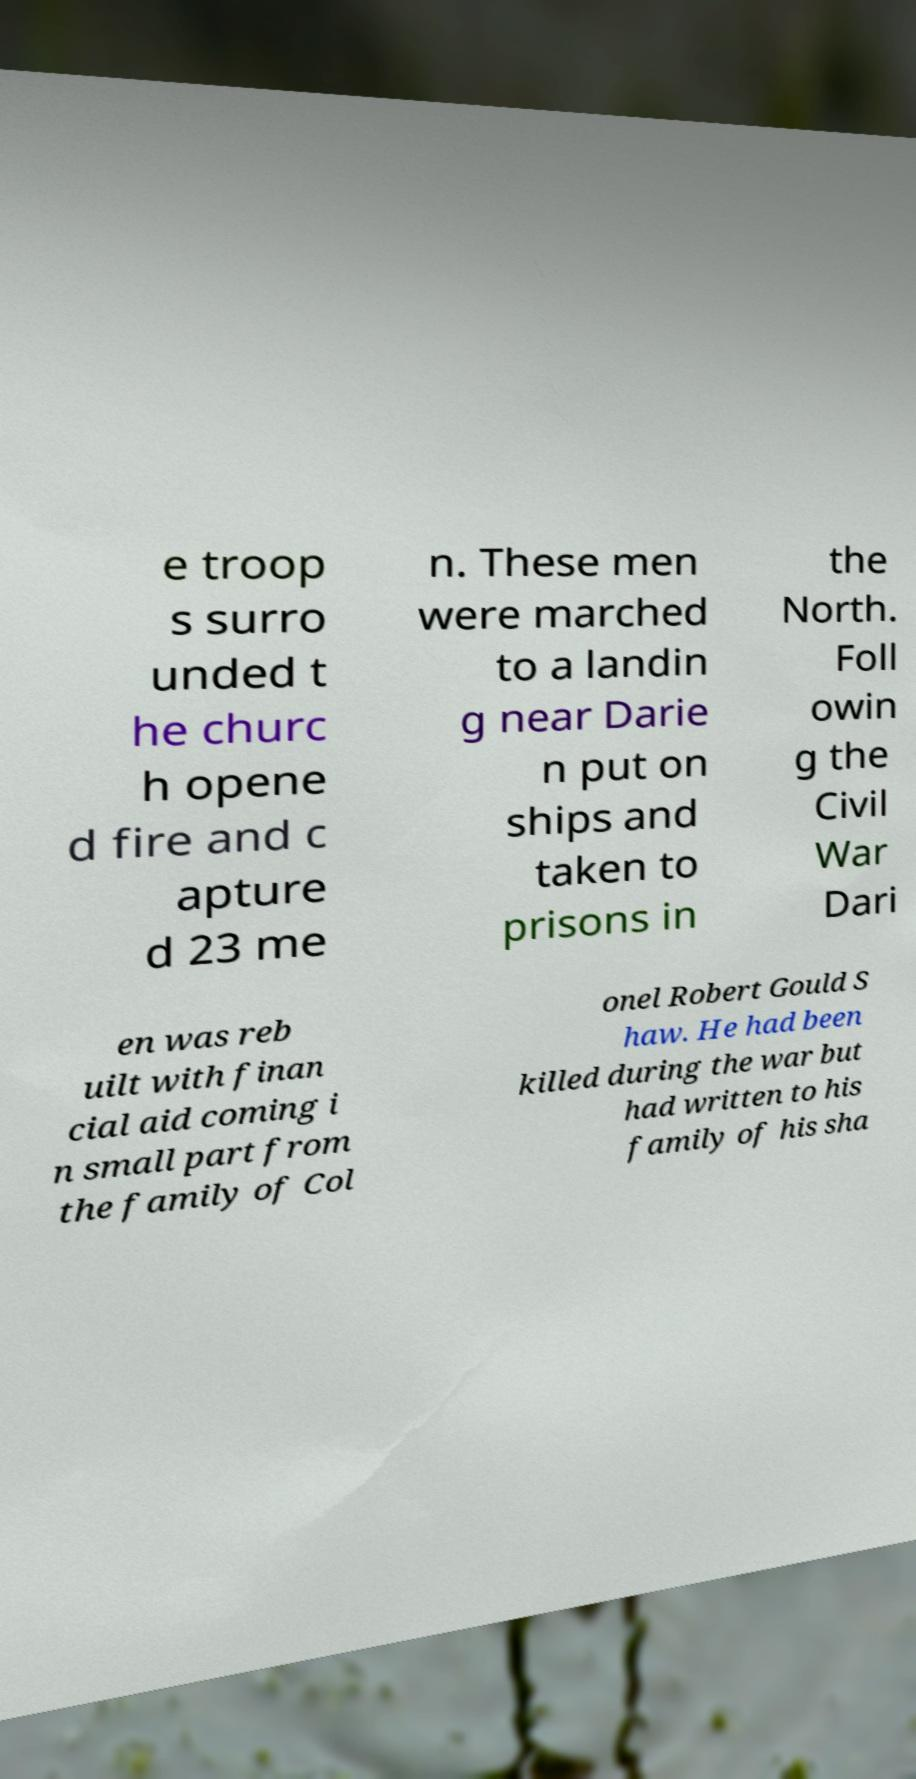Can you read and provide the text displayed in the image?This photo seems to have some interesting text. Can you extract and type it out for me? e troop s surro unded t he churc h opene d fire and c apture d 23 me n. These men were marched to a landin g near Darie n put on ships and taken to prisons in the North. Foll owin g the Civil War Dari en was reb uilt with finan cial aid coming i n small part from the family of Col onel Robert Gould S haw. He had been killed during the war but had written to his family of his sha 